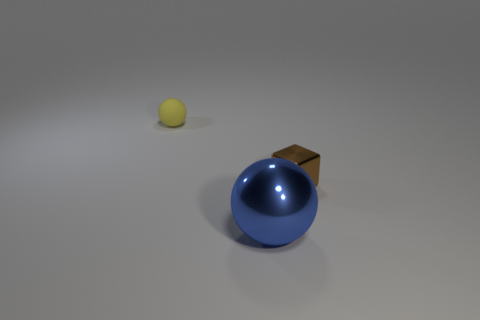Is there any other thing that has the same shape as the brown metal object?
Ensure brevity in your answer.  No. Is the number of big metallic balls on the right side of the small brown object less than the number of purple things?
Give a very brief answer. No. What color is the other object that is made of the same material as the big thing?
Make the answer very short. Brown. What is the size of the metal object that is right of the large metallic thing?
Keep it short and to the point. Small. Is the big blue sphere made of the same material as the tiny brown cube?
Provide a short and direct response. Yes. There is a ball behind the object right of the blue object; is there a large metal sphere that is to the left of it?
Make the answer very short. No. The matte sphere has what color?
Make the answer very short. Yellow. What color is the metal cube that is the same size as the yellow rubber ball?
Keep it short and to the point. Brown. Does the tiny thing that is behind the tiny metal object have the same shape as the blue metallic object?
Your answer should be very brief. Yes. What is the color of the object that is right of the blue ball left of the thing that is right of the big sphere?
Make the answer very short. Brown. 